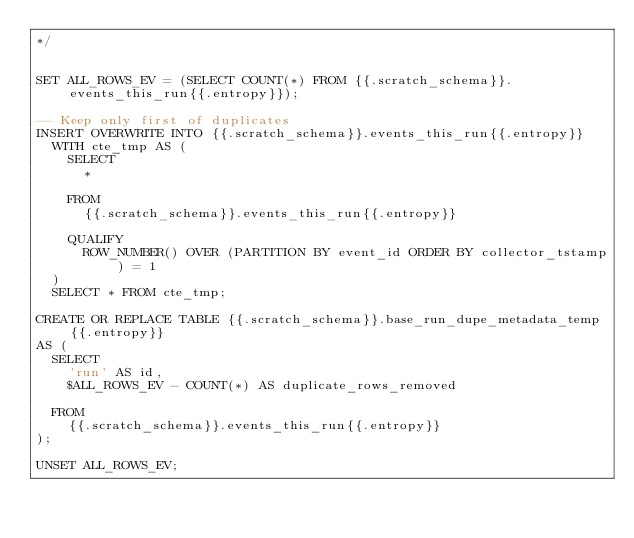Convert code to text. <code><loc_0><loc_0><loc_500><loc_500><_SQL_>*/


SET ALL_ROWS_EV = (SELECT COUNT(*) FROM {{.scratch_schema}}.events_this_run{{.entropy}});

-- Keep only first of duplicates
INSERT OVERWRITE INTO {{.scratch_schema}}.events_this_run{{.entropy}}
  WITH cte_tmp AS (
    SELECT
      *

    FROM
      {{.scratch_schema}}.events_this_run{{.entropy}}

    QUALIFY
      ROW_NUMBER() OVER (PARTITION BY event_id ORDER BY collector_tstamp) = 1
  )
  SELECT * FROM cte_tmp;

CREATE OR REPLACE TABLE {{.scratch_schema}}.base_run_dupe_metadata_temp{{.entropy}}
AS (
  SELECT
    'run' AS id,
    $ALL_ROWS_EV - COUNT(*) AS duplicate_rows_removed

  FROM
    {{.scratch_schema}}.events_this_run{{.entropy}}
);

UNSET ALL_ROWS_EV;
</code> 